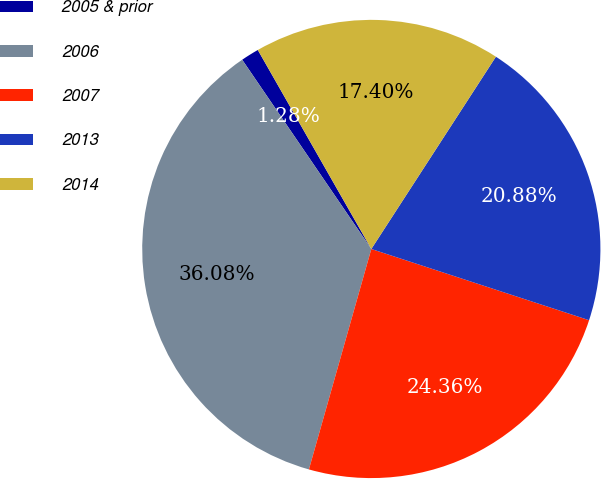Convert chart. <chart><loc_0><loc_0><loc_500><loc_500><pie_chart><fcel>2005 & prior<fcel>2006<fcel>2007<fcel>2013<fcel>2014<nl><fcel>1.28%<fcel>36.08%<fcel>24.36%<fcel>20.88%<fcel>17.4%<nl></chart> 